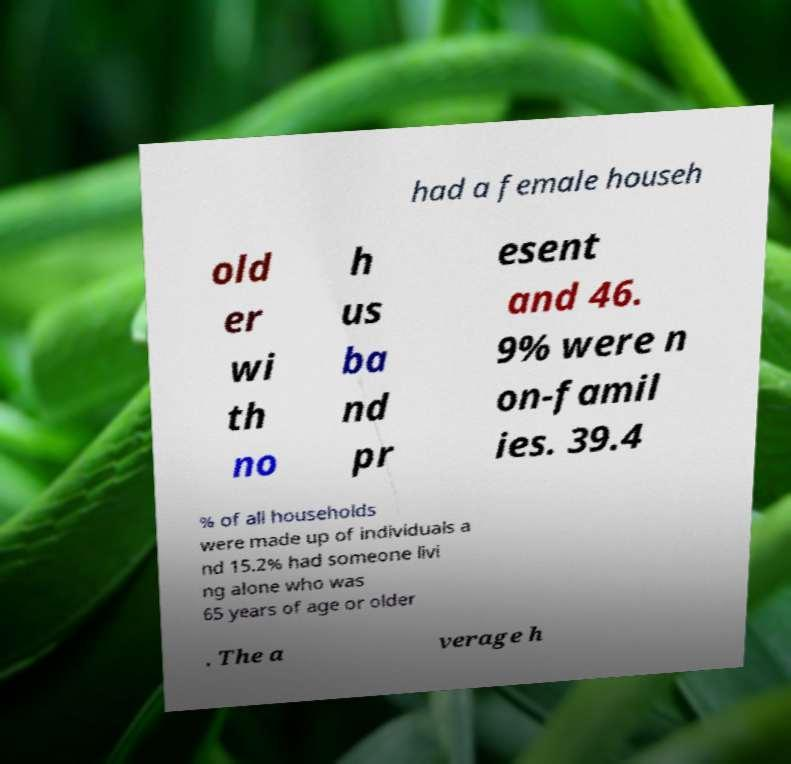For documentation purposes, I need the text within this image transcribed. Could you provide that? had a female househ old er wi th no h us ba nd pr esent and 46. 9% were n on-famil ies. 39.4 % of all households were made up of individuals a nd 15.2% had someone livi ng alone who was 65 years of age or older . The a verage h 